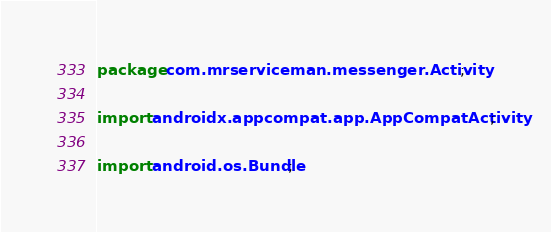<code> <loc_0><loc_0><loc_500><loc_500><_Java_>package com.mrserviceman.messenger.Activity;

import androidx.appcompat.app.AppCompatActivity;

import android.os.Bundle;</code> 